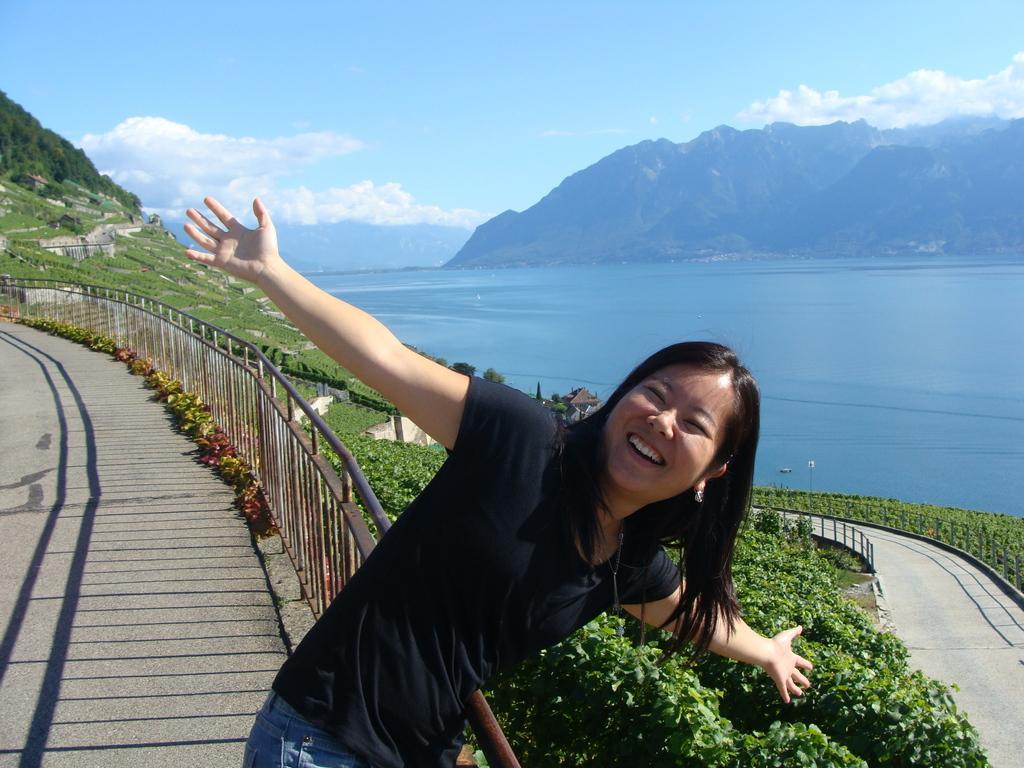Can you describe this image briefly? In this picture we can see a woman standing and smiling, fence, path, trees, mountains, water and in the background we can see the sky with clouds. 